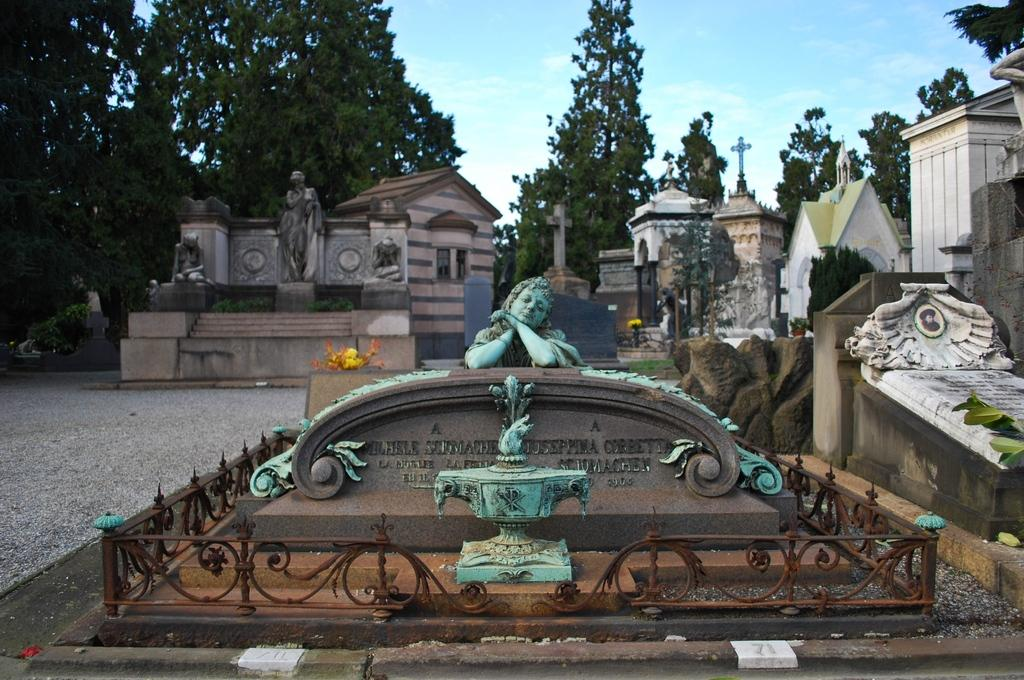What type of art can be seen in the image? There are sculptures in the image. What type of barrier is present in the image? There is fencing in the image. What type of structures are visible in the image? There are houses in the image. What type of vegetation is present in the image? There are trees in the image. What is visible in the background of the image? The sky is visible in the background of the image. Where is the faucet located in the image? There is no faucet present in the image. What type of yoke is being used by the sculptures in the image? There are no yokes present in the image, as it features sculptures and not animals or vehicles that would require a yoke. 